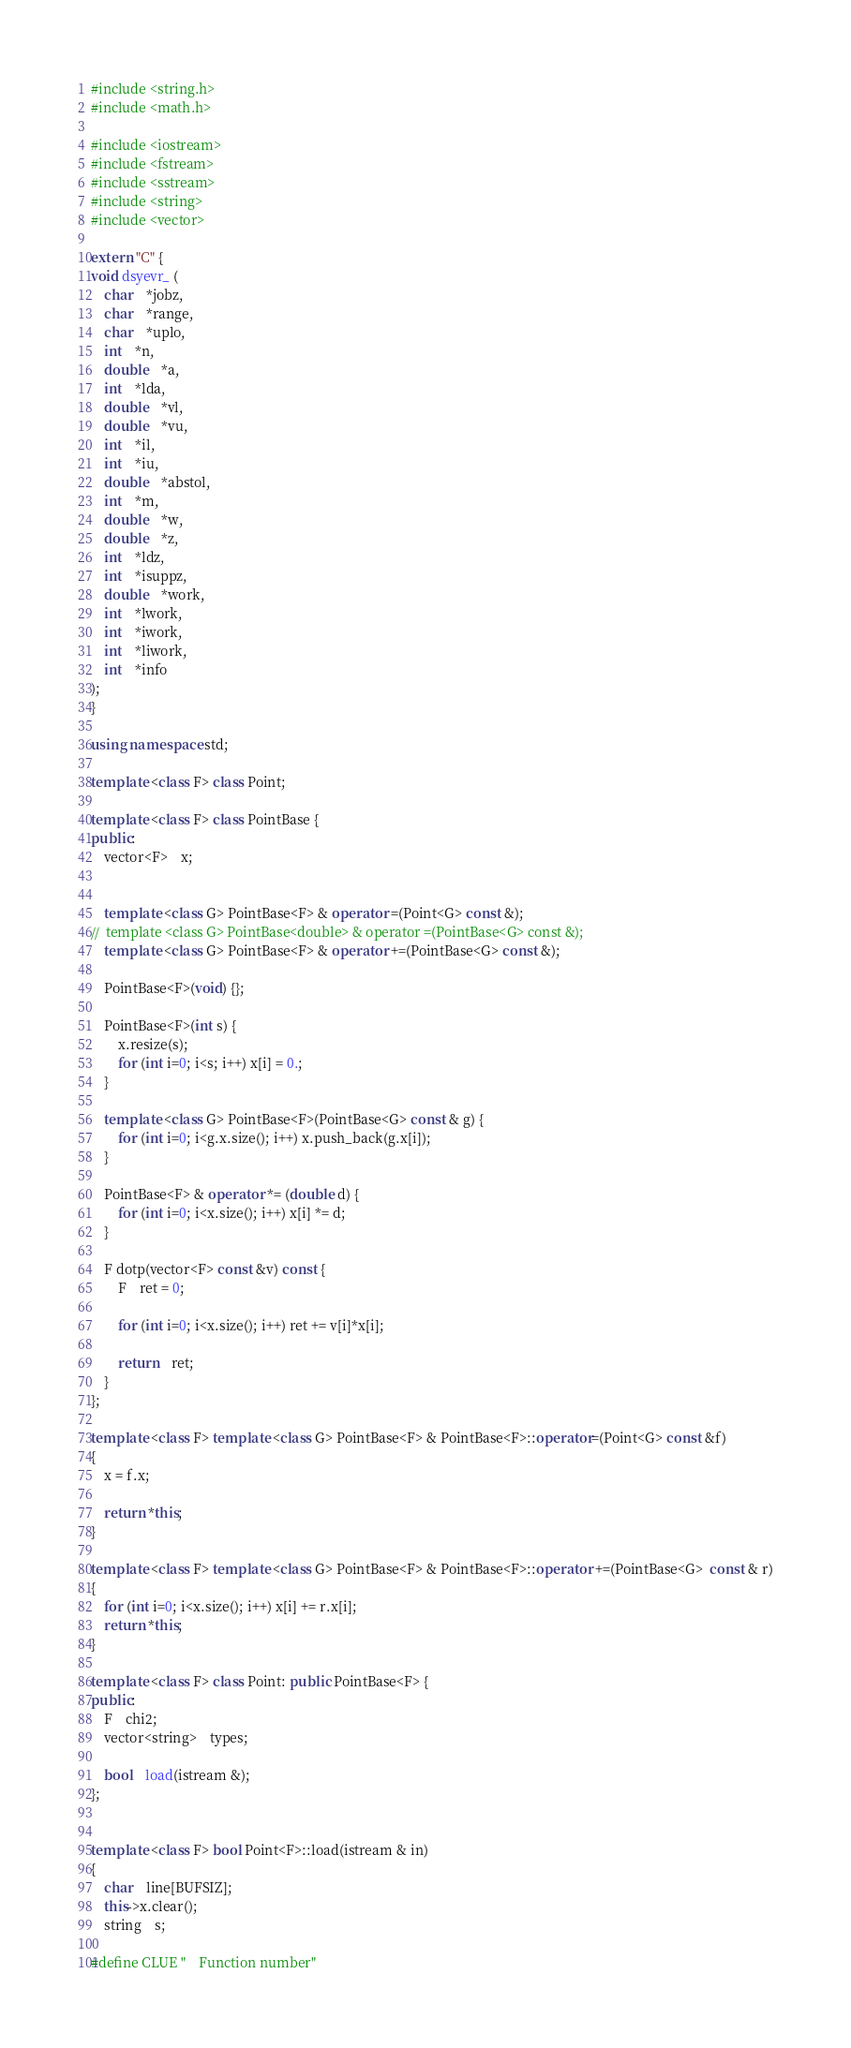Convert code to text. <code><loc_0><loc_0><loc_500><loc_500><_C++_>#include <string.h>
#include <math.h>

#include <iostream>
#include <fstream>
#include <sstream>
#include <string>
#include <vector>

extern "C" {
void dsyevr_ (
	char	*jobz,
	char	*range,
	char	*uplo,
	int	*n,
	double	*a,
	int	*lda,
	double	*vl,
	double	*vu,
	int	*il,
	int	*iu,
	double	*abstol,
	int	*m,
	double	*w,
	double	*z,
	int	*ldz,
	int	*isuppz,
	double	*work,
	int	*lwork,
	int	*iwork,
	int	*liwork,
	int	*info
);
}

using namespace std;

template <class F> class Point;

template <class F> class PointBase {
public:
	vector<F>	x;


	template <class G> PointBase<F> & operator =(Point<G> const &);
//	template <class G> PointBase<double> & operator =(PointBase<G> const &);
	template <class G> PointBase<F> & operator +=(PointBase<G> const &);

	PointBase<F>(void) {}; 

	PointBase<F>(int s) {
		x.resize(s); 
		for (int i=0; i<s; i++) x[i] = 0.;
	}

	template <class G> PointBase<F>(PointBase<G> const & g) {
		for (int i=0; i<g.x.size(); i++) x.push_back(g.x[i]);
	}

	PointBase<F> & operator *= (double d) {
		for (int i=0; i<x.size(); i++) x[i] *= d;
	}

	F dotp(vector<F> const &v) const {
		F	ret = 0;

		for (int i=0; i<x.size(); i++) ret += v[i]*x[i];

		return	ret;
	}
};

template <class F> template <class G> PointBase<F> & PointBase<F>::operator=(Point<G> const &f)
{
	x = f.x;

	return *this;
}

template <class F> template <class G> PointBase<F> & PointBase<F>::operator +=(PointBase<G>  const & r)
{
	for (int i=0; i<x.size(); i++) x[i] += r.x[i];
	return *this;
}

template <class F> class Point: public PointBase<F> {
public:
	F	chi2;
	vector<string>	types;

	bool	load(istream &);
};


template <class F> bool Point<F>::load(istream & in)
{
	char	line[BUFSIZ];
	this->x.clear();
	string	s;

#define CLUE	"    Function number"
</code> 